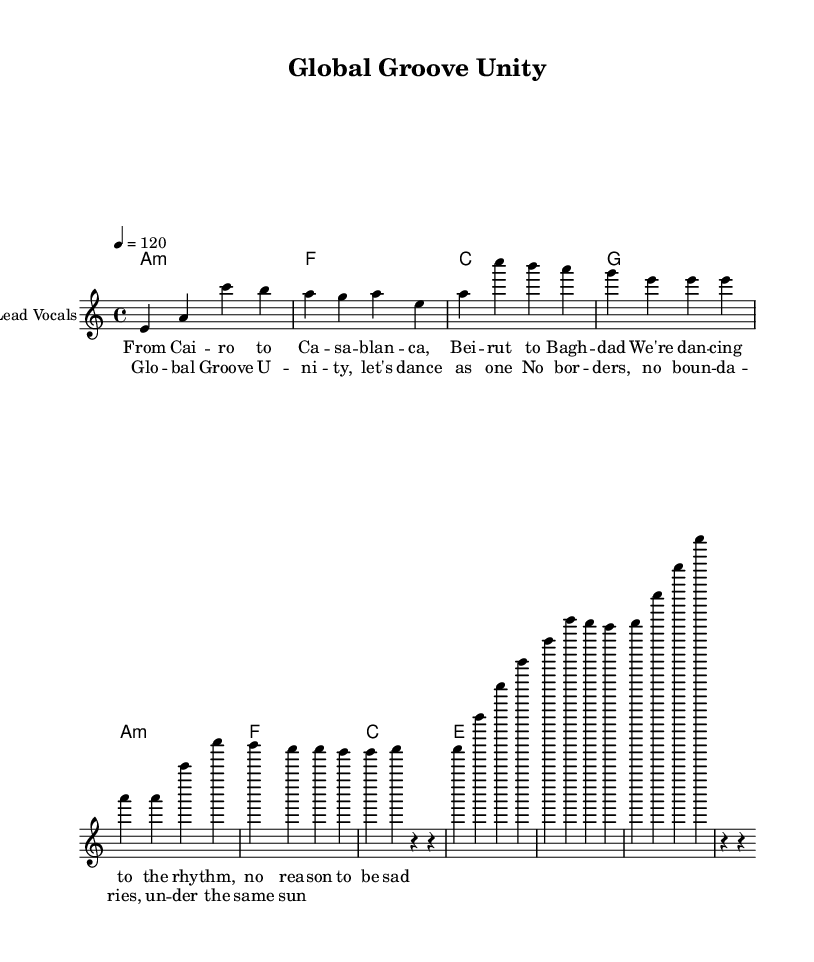What is the key signature of this music? The key signature is A minor, which contains no sharps or flats, indicated at the beginning of the staff.
Answer: A minor What is the time signature of this music? The time signature is 4/4, which is noted at the start of the composition, indicating four beats per measure.
Answer: 4/4 What is the tempo marking of this music? The tempo marking is 120 beats per minute, specified in the tempo section, indicating the speed at which the piece should be played.
Answer: 120 How many measures are there in the chorus? The chorus consists of four measures, clearly marked by the musical notation and lyrics in the score.
Answer: Four measures Which lyric corresponds to the first melody note E? The lyric "From Cai" corresponds to the first melody note E, as it is positioned directly above this note in the score, indicating its timing.
Answer: From Cai What musical form does this piece predominantly follow? The piece follows a verse-chorus structure, as evidenced by the distinct sections labeled and organized throughout the score.
Answer: Verse-chorus What is the overall theme promoted in the lyrics? The overall theme is unity and togetherness across different cultures, as expressed in the lyrics highlighting dancing and celebrating under the same sun.
Answer: Unity 